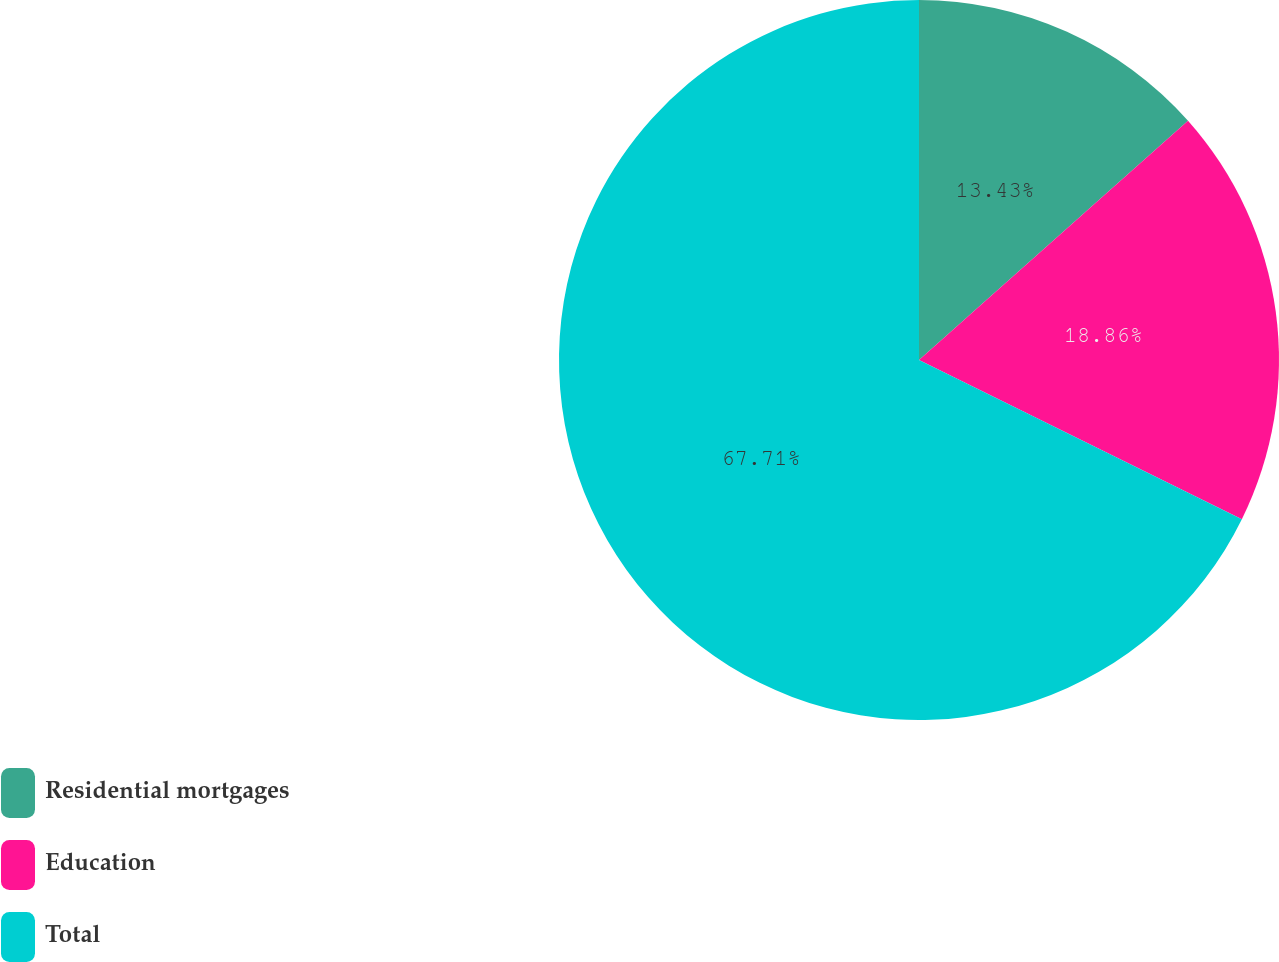<chart> <loc_0><loc_0><loc_500><loc_500><pie_chart><fcel>Residential mortgages<fcel>Education<fcel>Total<nl><fcel>13.43%<fcel>18.86%<fcel>67.7%<nl></chart> 